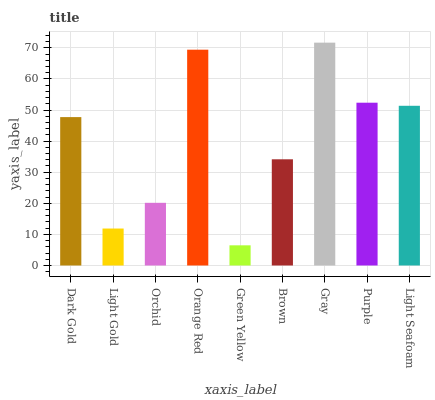Is Green Yellow the minimum?
Answer yes or no. Yes. Is Gray the maximum?
Answer yes or no. Yes. Is Light Gold the minimum?
Answer yes or no. No. Is Light Gold the maximum?
Answer yes or no. No. Is Dark Gold greater than Light Gold?
Answer yes or no. Yes. Is Light Gold less than Dark Gold?
Answer yes or no. Yes. Is Light Gold greater than Dark Gold?
Answer yes or no. No. Is Dark Gold less than Light Gold?
Answer yes or no. No. Is Dark Gold the high median?
Answer yes or no. Yes. Is Dark Gold the low median?
Answer yes or no. Yes. Is Brown the high median?
Answer yes or no. No. Is Green Yellow the low median?
Answer yes or no. No. 